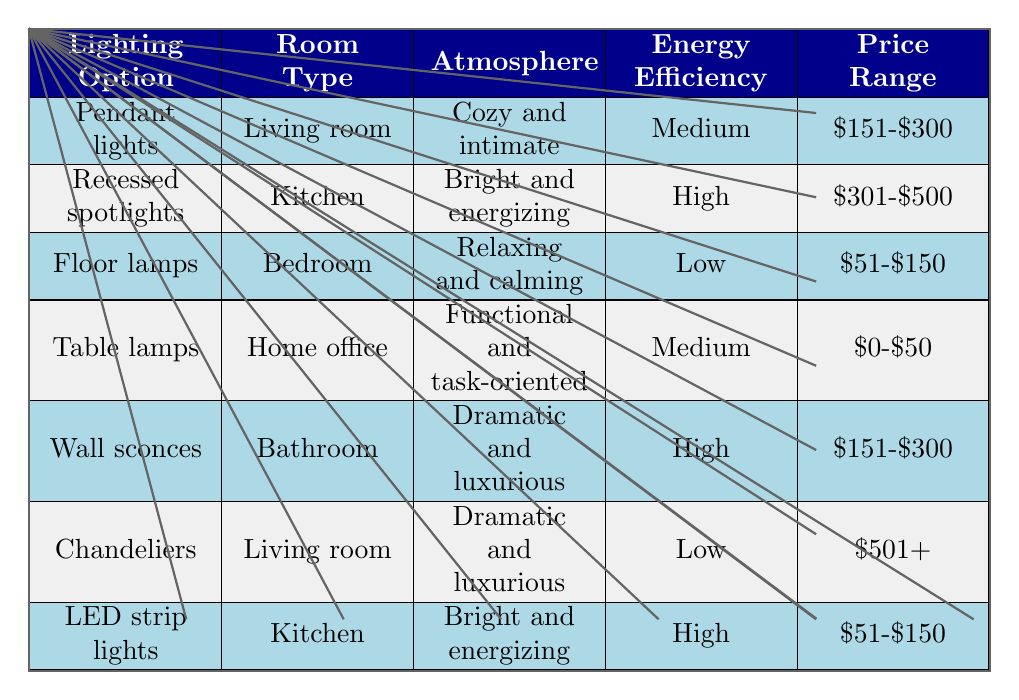What is the energy efficiency rating for floor lamps? The energy efficiency rating for floor lamps is located in their corresponding row, where it is listed as "Low."
Answer: Low Which lighting option is associated with a "cozy and intimate" atmosphere in the living room? The row for the living room indicates that pendant lights are associated with a "cozy and intimate" atmosphere.
Answer: Pendant lights How many lighting options are rated high for energy efficiency? By checking the table, both recessed spotlights and LED strip lights have a high energy efficiency rating. Therefore, there are two options rated high.
Answer: 2 Is it true that all lighting options for the kitchen create a "bright and energizing" atmosphere? The table shows two lighting options for the kitchen: recessed spotlights and LED strip lights, both of which indeed create a "bright and energizing" atmosphere.
Answer: Yes Which lighting option for the bedroom is both low in energy efficiency and costs between $51-$150? The table reveals that floor lamps are the only option for the bedroom that fits both criteria: it has low energy efficiency and is priced between $51-$150.
Answer: Floor lamps What is the price range for wall sconces? The price range for wall sconces, as detailed in their row, is between $151 and $300.
Answer: $151-$300 Which room type has the highest energy efficiency rating? The highest energy efficiency rating noted in the table is for the kitchen, where both lighting options have high ratings—recessed spotlights and LED strip lights.
Answer: Kitchen If you wanted a dramatic and luxurious atmosphere, available options are chandeliers and wall sconces. Which one is energy efficient? By looking at the energy ratings in the table, wall sconces have a high rating, while chandeliers are rated low in energy efficiency. Thus, the energy-efficient option is wall sconces.
Answer: Wall sconces 